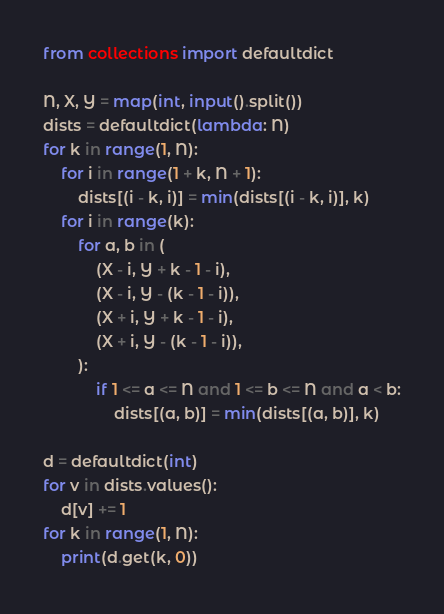<code> <loc_0><loc_0><loc_500><loc_500><_Python_>from collections import defaultdict

N, X, Y = map(int, input().split())
dists = defaultdict(lambda: N)
for k in range(1, N):
    for i in range(1 + k, N + 1):
        dists[(i - k, i)] = min(dists[(i - k, i)], k)
    for i in range(k):
        for a, b in (
            (X - i, Y + k - 1 - i),
            (X - i, Y - (k - 1 - i)),
            (X + i, Y + k - 1 - i),
            (X + i, Y - (k - 1 - i)),
        ):
            if 1 <= a <= N and 1 <= b <= N and a < b:
                dists[(a, b)] = min(dists[(a, b)], k)

d = defaultdict(int)
for v in dists.values():
    d[v] += 1
for k in range(1, N):
    print(d.get(k, 0))</code> 